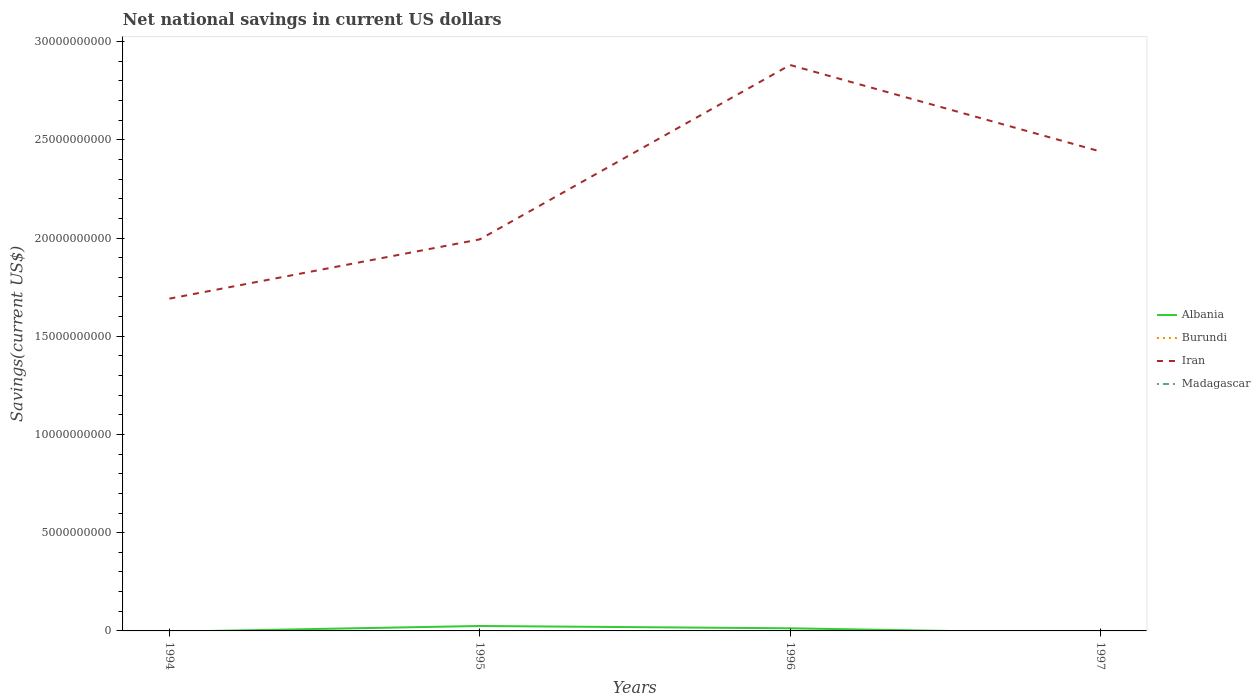Across all years, what is the maximum net national savings in Iran?
Offer a very short reply. 1.69e+1. What is the total net national savings in Iran in the graph?
Keep it short and to the point. 4.40e+09. What is the difference between the highest and the second highest net national savings in Iran?
Your answer should be compact. 1.19e+1. Is the net national savings in Iran strictly greater than the net national savings in Burundi over the years?
Make the answer very short. No. How many lines are there?
Offer a very short reply. 2. Does the graph contain grids?
Make the answer very short. No. Where does the legend appear in the graph?
Give a very brief answer. Center right. How are the legend labels stacked?
Make the answer very short. Vertical. What is the title of the graph?
Provide a succinct answer. Net national savings in current US dollars. Does "Lesotho" appear as one of the legend labels in the graph?
Give a very brief answer. No. What is the label or title of the Y-axis?
Give a very brief answer. Savings(current US$). What is the Savings(current US$) of Iran in 1994?
Your answer should be very brief. 1.69e+1. What is the Savings(current US$) of Madagascar in 1994?
Make the answer very short. 0. What is the Savings(current US$) of Albania in 1995?
Offer a very short reply. 2.51e+08. What is the Savings(current US$) in Iran in 1995?
Keep it short and to the point. 1.99e+1. What is the Savings(current US$) of Madagascar in 1995?
Make the answer very short. 0. What is the Savings(current US$) in Albania in 1996?
Provide a succinct answer. 1.33e+08. What is the Savings(current US$) in Burundi in 1996?
Your response must be concise. 0. What is the Savings(current US$) in Iran in 1996?
Offer a terse response. 2.88e+1. What is the Savings(current US$) of Burundi in 1997?
Provide a short and direct response. 0. What is the Savings(current US$) in Iran in 1997?
Provide a succinct answer. 2.44e+1. Across all years, what is the maximum Savings(current US$) in Albania?
Your answer should be compact. 2.51e+08. Across all years, what is the maximum Savings(current US$) in Iran?
Give a very brief answer. 2.88e+1. Across all years, what is the minimum Savings(current US$) of Iran?
Your answer should be compact. 1.69e+1. What is the total Savings(current US$) in Albania in the graph?
Your answer should be very brief. 3.85e+08. What is the total Savings(current US$) in Burundi in the graph?
Make the answer very short. 0. What is the total Savings(current US$) of Iran in the graph?
Ensure brevity in your answer.  9.01e+1. What is the difference between the Savings(current US$) of Iran in 1994 and that in 1995?
Offer a terse response. -3.02e+09. What is the difference between the Savings(current US$) of Iran in 1994 and that in 1996?
Ensure brevity in your answer.  -1.19e+1. What is the difference between the Savings(current US$) in Iran in 1994 and that in 1997?
Offer a terse response. -7.49e+09. What is the difference between the Savings(current US$) of Albania in 1995 and that in 1996?
Your response must be concise. 1.18e+08. What is the difference between the Savings(current US$) in Iran in 1995 and that in 1996?
Provide a short and direct response. -8.88e+09. What is the difference between the Savings(current US$) in Iran in 1995 and that in 1997?
Your answer should be compact. -4.47e+09. What is the difference between the Savings(current US$) in Iran in 1996 and that in 1997?
Offer a very short reply. 4.40e+09. What is the difference between the Savings(current US$) of Albania in 1995 and the Savings(current US$) of Iran in 1996?
Provide a succinct answer. -2.86e+1. What is the difference between the Savings(current US$) in Albania in 1995 and the Savings(current US$) in Iran in 1997?
Ensure brevity in your answer.  -2.42e+1. What is the difference between the Savings(current US$) in Albania in 1996 and the Savings(current US$) in Iran in 1997?
Offer a very short reply. -2.43e+1. What is the average Savings(current US$) of Albania per year?
Give a very brief answer. 9.61e+07. What is the average Savings(current US$) in Burundi per year?
Provide a succinct answer. 0. What is the average Savings(current US$) of Iran per year?
Provide a short and direct response. 2.25e+1. What is the average Savings(current US$) of Madagascar per year?
Offer a very short reply. 0. In the year 1995, what is the difference between the Savings(current US$) of Albania and Savings(current US$) of Iran?
Provide a succinct answer. -1.97e+1. In the year 1996, what is the difference between the Savings(current US$) of Albania and Savings(current US$) of Iran?
Keep it short and to the point. -2.87e+1. What is the ratio of the Savings(current US$) in Iran in 1994 to that in 1995?
Offer a very short reply. 0.85. What is the ratio of the Savings(current US$) in Iran in 1994 to that in 1996?
Your response must be concise. 0.59. What is the ratio of the Savings(current US$) of Iran in 1994 to that in 1997?
Provide a short and direct response. 0.69. What is the ratio of the Savings(current US$) in Albania in 1995 to that in 1996?
Your answer should be compact. 1.88. What is the ratio of the Savings(current US$) in Iran in 1995 to that in 1996?
Make the answer very short. 0.69. What is the ratio of the Savings(current US$) in Iran in 1995 to that in 1997?
Offer a terse response. 0.82. What is the ratio of the Savings(current US$) in Iran in 1996 to that in 1997?
Ensure brevity in your answer.  1.18. What is the difference between the highest and the second highest Savings(current US$) of Iran?
Ensure brevity in your answer.  4.40e+09. What is the difference between the highest and the lowest Savings(current US$) of Albania?
Your response must be concise. 2.51e+08. What is the difference between the highest and the lowest Savings(current US$) of Iran?
Your answer should be very brief. 1.19e+1. 